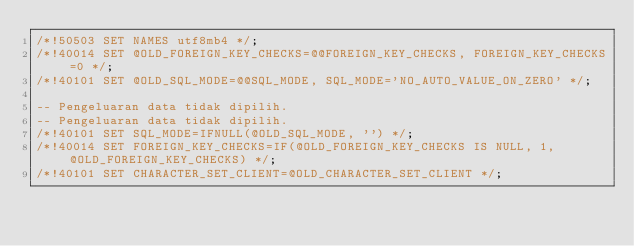Convert code to text. <code><loc_0><loc_0><loc_500><loc_500><_SQL_>/*!50503 SET NAMES utf8mb4 */;
/*!40014 SET @OLD_FOREIGN_KEY_CHECKS=@@FOREIGN_KEY_CHECKS, FOREIGN_KEY_CHECKS=0 */;
/*!40101 SET @OLD_SQL_MODE=@@SQL_MODE, SQL_MODE='NO_AUTO_VALUE_ON_ZERO' */;

-- Pengeluaran data tidak dipilih.
-- Pengeluaran data tidak dipilih.
/*!40101 SET SQL_MODE=IFNULL(@OLD_SQL_MODE, '') */;
/*!40014 SET FOREIGN_KEY_CHECKS=IF(@OLD_FOREIGN_KEY_CHECKS IS NULL, 1, @OLD_FOREIGN_KEY_CHECKS) */;
/*!40101 SET CHARACTER_SET_CLIENT=@OLD_CHARACTER_SET_CLIENT */;
</code> 